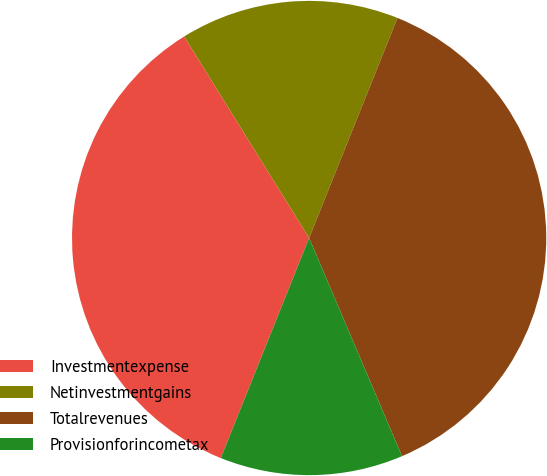Convert chart to OTSL. <chart><loc_0><loc_0><loc_500><loc_500><pie_chart><fcel>Investmentexpense<fcel>Netinvestmentgains<fcel>Totalrevenues<fcel>Provisionforincometax<nl><fcel>35.09%<fcel>14.91%<fcel>37.52%<fcel>12.48%<nl></chart> 